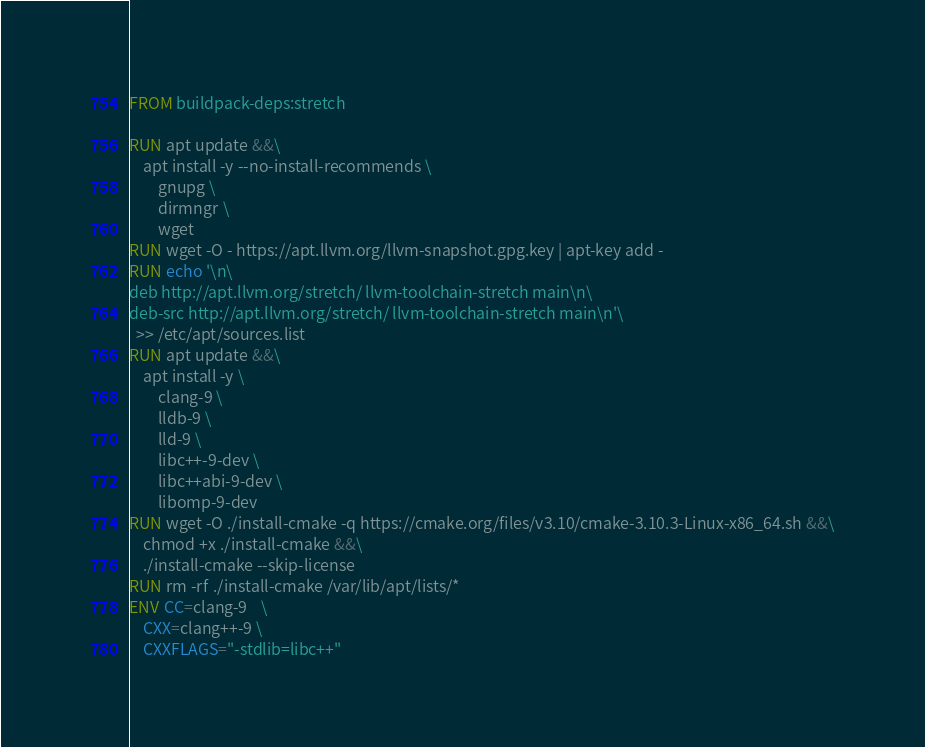Convert code to text. <code><loc_0><loc_0><loc_500><loc_500><_Dockerfile_>FROM buildpack-deps:stretch

RUN apt update &&\
    apt install -y --no-install-recommends \
        gnupg \
        dirmngr \
        wget
RUN wget -O - https://apt.llvm.org/llvm-snapshot.gpg.key | apt-key add -
RUN echo '\n\
deb http://apt.llvm.org/stretch/ llvm-toolchain-stretch main\n\
deb-src http://apt.llvm.org/stretch/ llvm-toolchain-stretch main\n'\
  >> /etc/apt/sources.list
RUN apt update &&\
    apt install -y \
        clang-9 \
        lldb-9 \
        lld-9 \
        libc++-9-dev \
        libc++abi-9-dev \
        libomp-9-dev
RUN wget -O ./install-cmake -q https://cmake.org/files/v3.10/cmake-3.10.3-Linux-x86_64.sh &&\
    chmod +x ./install-cmake &&\
    ./install-cmake --skip-license
RUN rm -rf ./install-cmake /var/lib/apt/lists/*
ENV CC=clang-9    \
    CXX=clang++-9 \
    CXXFLAGS="-stdlib=libc++"
</code> 